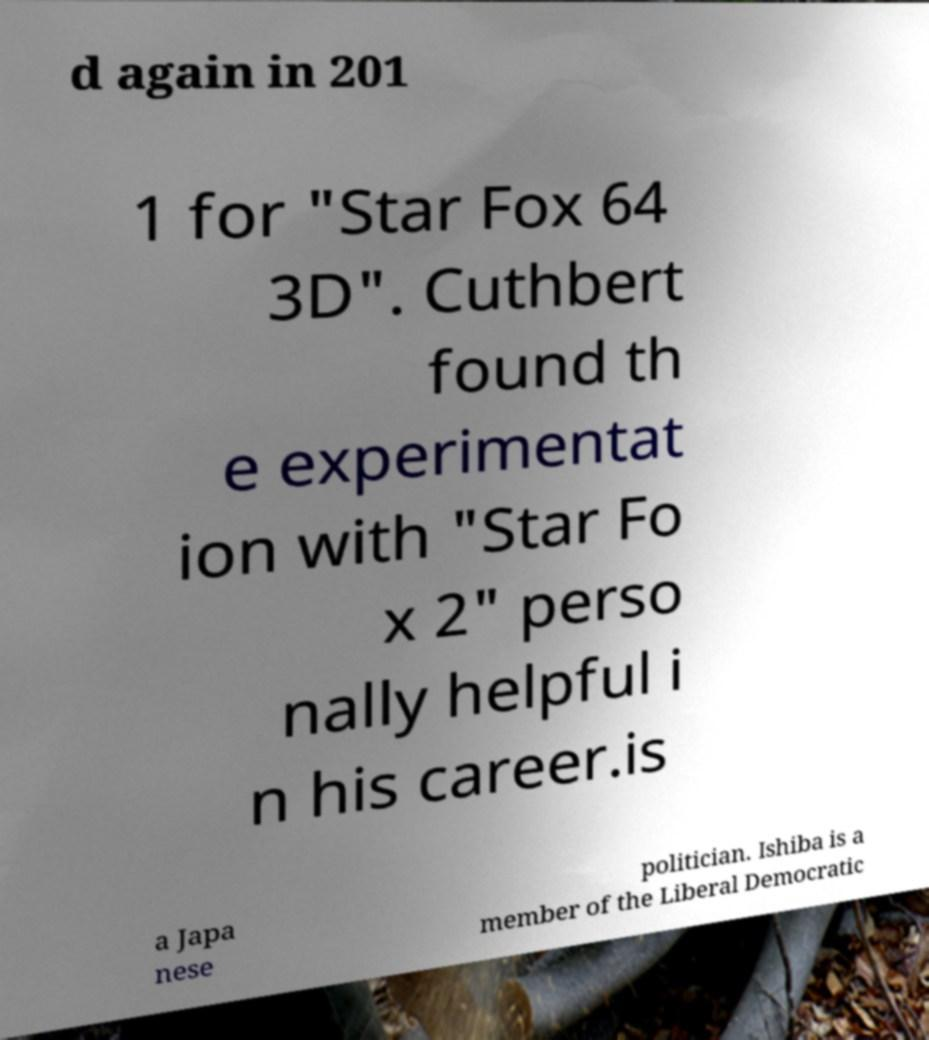Please read and relay the text visible in this image. What does it say? d again in 201 1 for "Star Fox 64 3D". Cuthbert found th e experimentat ion with "Star Fo x 2" perso nally helpful i n his career.is a Japa nese politician. Ishiba is a member of the Liberal Democratic 